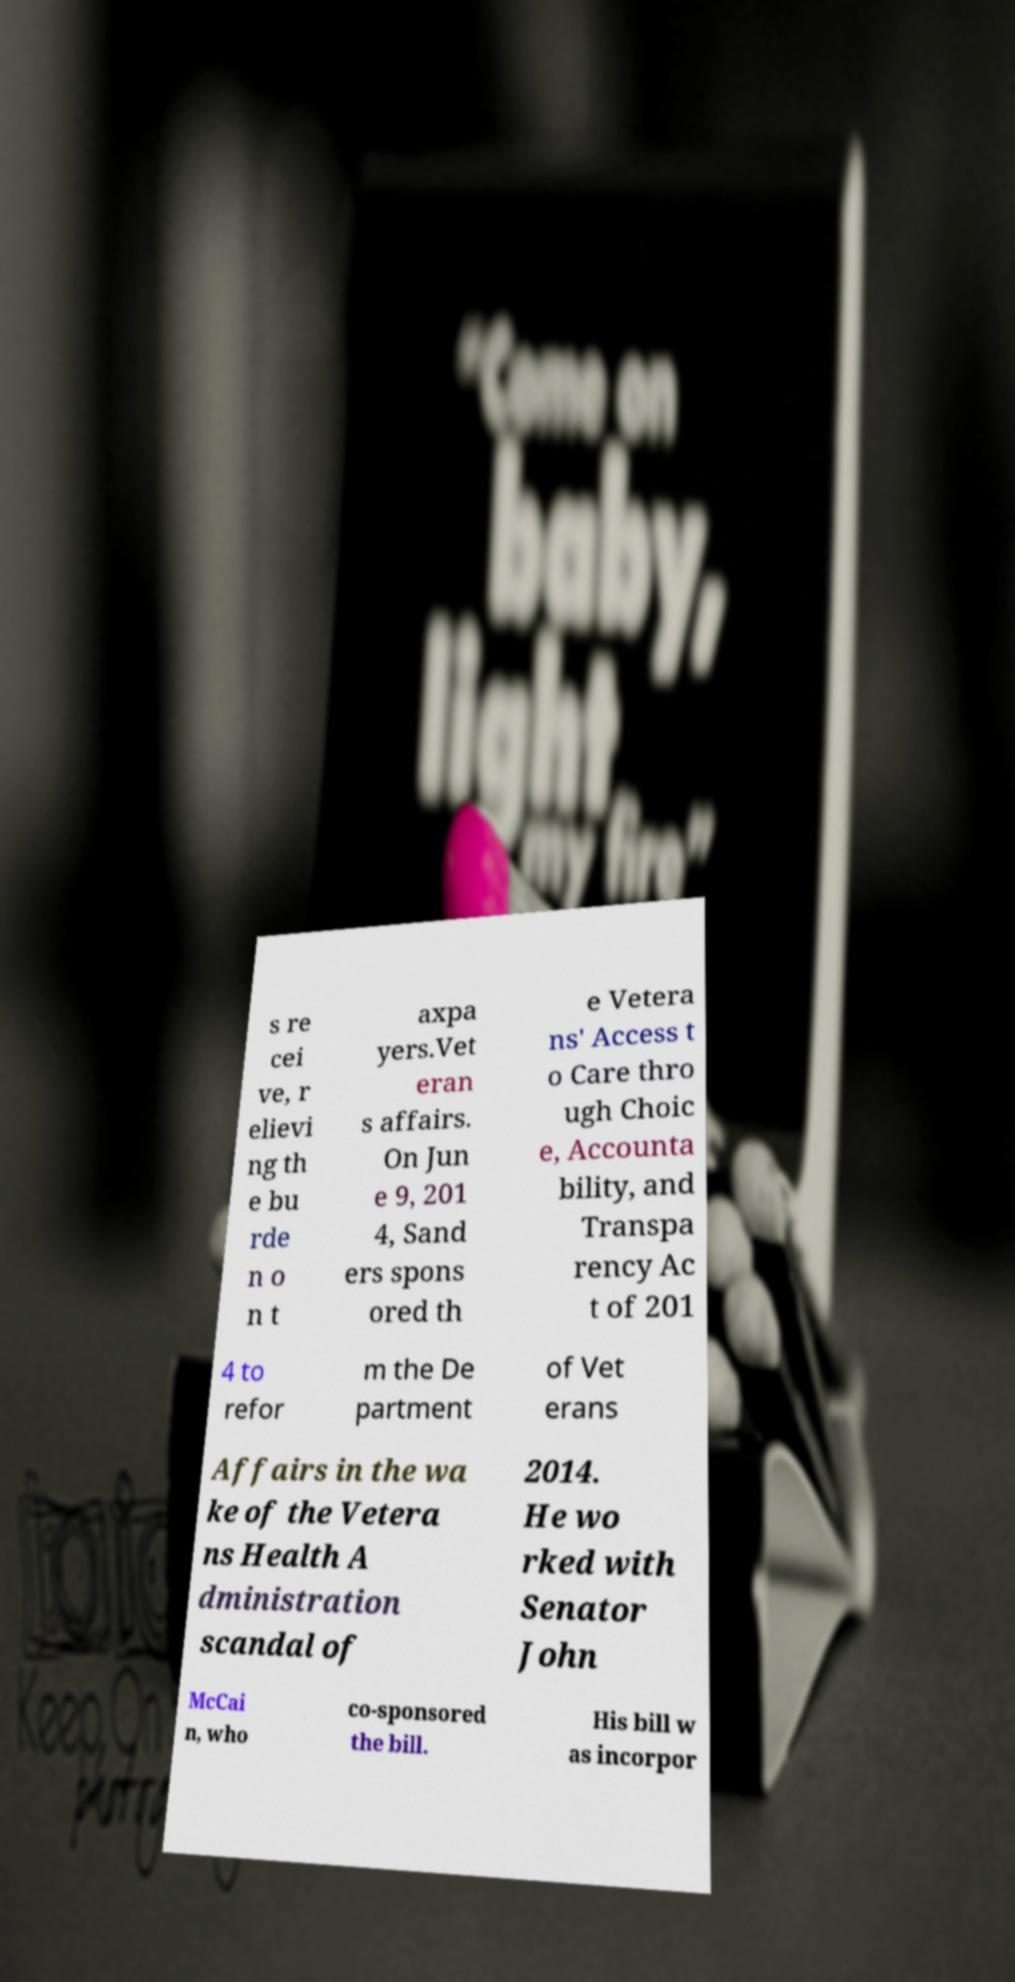Please identify and transcribe the text found in this image. s re cei ve, r elievi ng th e bu rde n o n t axpa yers.Vet eran s affairs. On Jun e 9, 201 4, Sand ers spons ored th e Vetera ns' Access t o Care thro ugh Choic e, Accounta bility, and Transpa rency Ac t of 201 4 to refor m the De partment of Vet erans Affairs in the wa ke of the Vetera ns Health A dministration scandal of 2014. He wo rked with Senator John McCai n, who co-sponsored the bill. His bill w as incorpor 